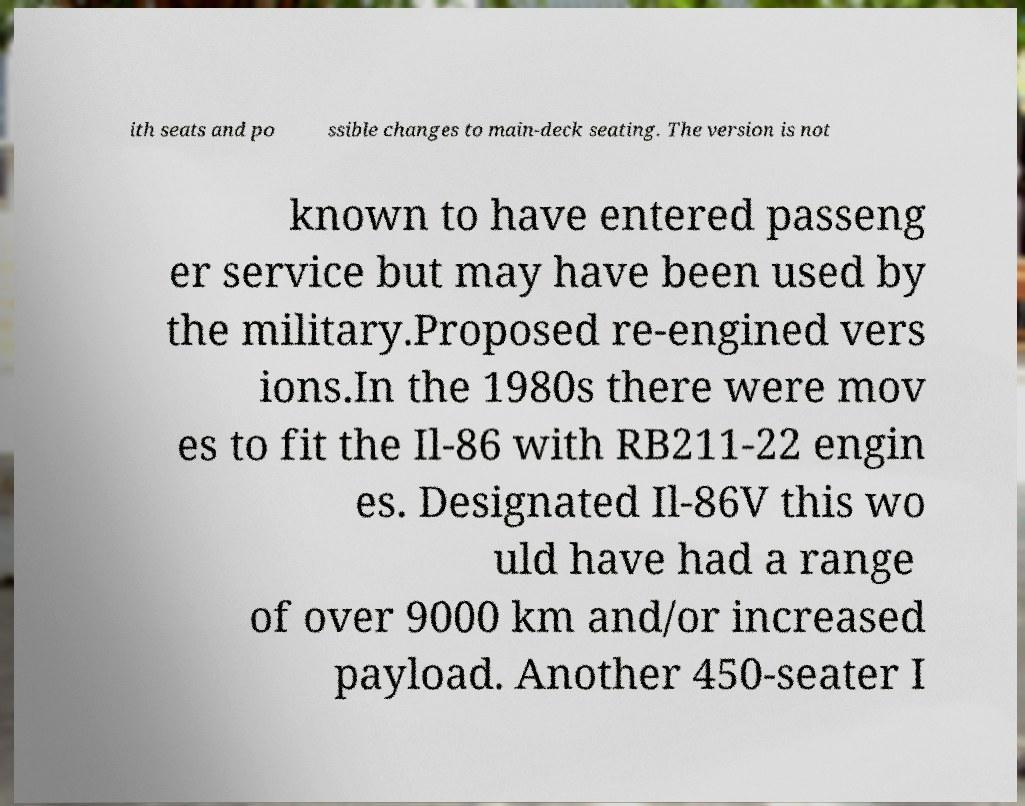Could you assist in decoding the text presented in this image and type it out clearly? ith seats and po ssible changes to main-deck seating. The version is not known to have entered passeng er service but may have been used by the military.Proposed re-engined vers ions.In the 1980s there were mov es to fit the Il-86 with RB211-22 engin es. Designated Il-86V this wo uld have had a range of over 9000 km and/or increased payload. Another 450-seater I 